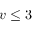<formula> <loc_0><loc_0><loc_500><loc_500>v \leq 3</formula> 